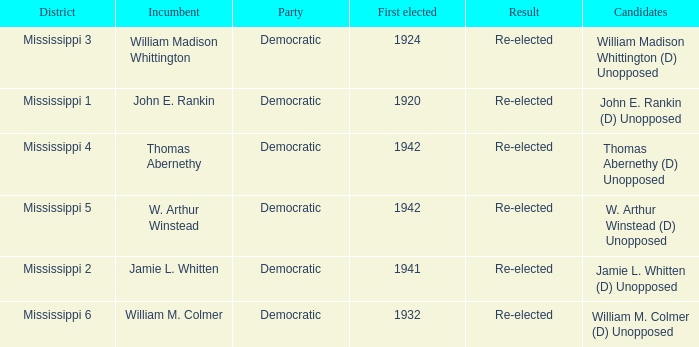Which district is jamie l. whitten from? Mississippi 2. 